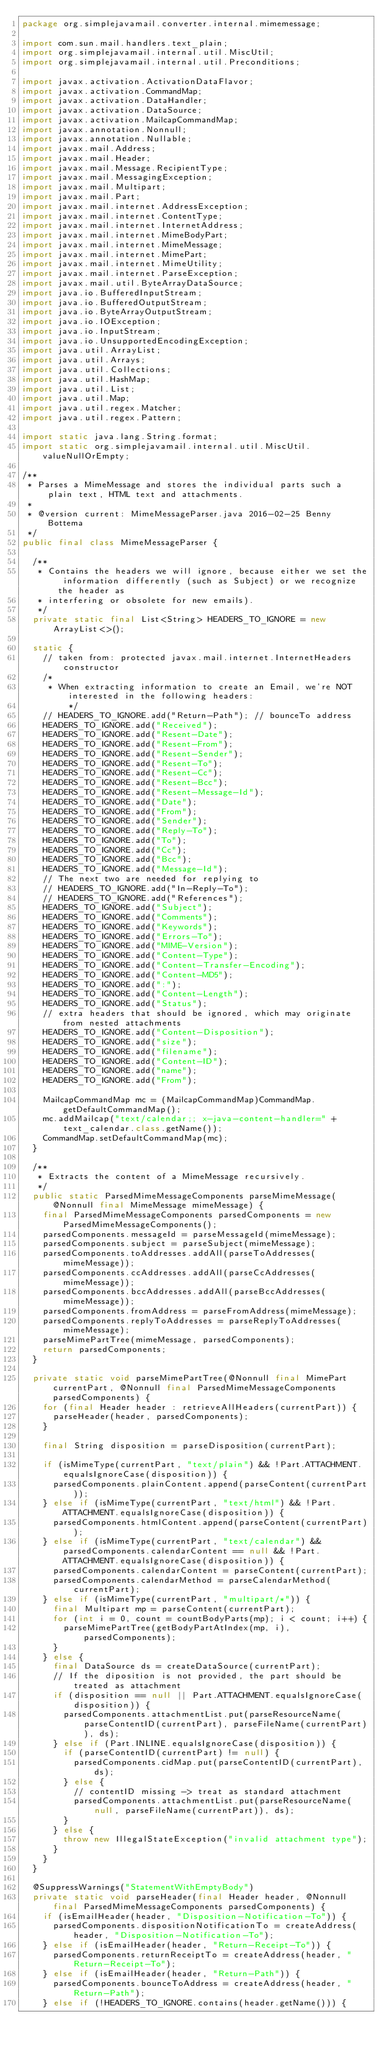<code> <loc_0><loc_0><loc_500><loc_500><_Java_>package org.simplejavamail.converter.internal.mimemessage;

import com.sun.mail.handlers.text_plain;
import org.simplejavamail.internal.util.MiscUtil;
import org.simplejavamail.internal.util.Preconditions;

import javax.activation.ActivationDataFlavor;
import javax.activation.CommandMap;
import javax.activation.DataHandler;
import javax.activation.DataSource;
import javax.activation.MailcapCommandMap;
import javax.annotation.Nonnull;
import javax.annotation.Nullable;
import javax.mail.Address;
import javax.mail.Header;
import javax.mail.Message.RecipientType;
import javax.mail.MessagingException;
import javax.mail.Multipart;
import javax.mail.Part;
import javax.mail.internet.AddressException;
import javax.mail.internet.ContentType;
import javax.mail.internet.InternetAddress;
import javax.mail.internet.MimeBodyPart;
import javax.mail.internet.MimeMessage;
import javax.mail.internet.MimePart;
import javax.mail.internet.MimeUtility;
import javax.mail.internet.ParseException;
import javax.mail.util.ByteArrayDataSource;
import java.io.BufferedInputStream;
import java.io.BufferedOutputStream;
import java.io.ByteArrayOutputStream;
import java.io.IOException;
import java.io.InputStream;
import java.io.UnsupportedEncodingException;
import java.util.ArrayList;
import java.util.Arrays;
import java.util.Collections;
import java.util.HashMap;
import java.util.List;
import java.util.Map;
import java.util.regex.Matcher;
import java.util.regex.Pattern;

import static java.lang.String.format;
import static org.simplejavamail.internal.util.MiscUtil.valueNullOrEmpty;

/**
 * Parses a MimeMessage and stores the individual parts such a plain text, HTML text and attachments.
 *
 * @version current: MimeMessageParser.java 2016-02-25 Benny Bottema
 */
public final class MimeMessageParser {
	
	/**
	 * Contains the headers we will ignore, because either we set the information differently (such as Subject) or we recognize the header as
	 * interfering or obsolete for new emails).
	 */
	private static final List<String> HEADERS_TO_IGNORE = new ArrayList<>();

	static {
		// taken from: protected javax.mail.internet.InternetHeaders constructor
		/*
		 * When extracting information to create an Email, we're NOT interested in the following headers:
         */
		// HEADERS_TO_IGNORE.add("Return-Path"); // bounceTo address
		HEADERS_TO_IGNORE.add("Received");
		HEADERS_TO_IGNORE.add("Resent-Date");
		HEADERS_TO_IGNORE.add("Resent-From");
		HEADERS_TO_IGNORE.add("Resent-Sender");
		HEADERS_TO_IGNORE.add("Resent-To");
		HEADERS_TO_IGNORE.add("Resent-Cc");
		HEADERS_TO_IGNORE.add("Resent-Bcc");
		HEADERS_TO_IGNORE.add("Resent-Message-Id");
		HEADERS_TO_IGNORE.add("Date");
		HEADERS_TO_IGNORE.add("From");
		HEADERS_TO_IGNORE.add("Sender");
		HEADERS_TO_IGNORE.add("Reply-To");
		HEADERS_TO_IGNORE.add("To");
		HEADERS_TO_IGNORE.add("Cc");
		HEADERS_TO_IGNORE.add("Bcc");
		HEADERS_TO_IGNORE.add("Message-Id");
		// The next two are needed for replying to
		// HEADERS_TO_IGNORE.add("In-Reply-To");
		// HEADERS_TO_IGNORE.add("References");
		HEADERS_TO_IGNORE.add("Subject");
		HEADERS_TO_IGNORE.add("Comments");
		HEADERS_TO_IGNORE.add("Keywords");
		HEADERS_TO_IGNORE.add("Errors-To");
		HEADERS_TO_IGNORE.add("MIME-Version");
		HEADERS_TO_IGNORE.add("Content-Type");
		HEADERS_TO_IGNORE.add("Content-Transfer-Encoding");
		HEADERS_TO_IGNORE.add("Content-MD5");
		HEADERS_TO_IGNORE.add(":");
		HEADERS_TO_IGNORE.add("Content-Length");
		HEADERS_TO_IGNORE.add("Status");
		// extra headers that should be ignored, which may originate from nested attachments
		HEADERS_TO_IGNORE.add("Content-Disposition");
		HEADERS_TO_IGNORE.add("size");
		HEADERS_TO_IGNORE.add("filename");
		HEADERS_TO_IGNORE.add("Content-ID");
		HEADERS_TO_IGNORE.add("name");
		HEADERS_TO_IGNORE.add("From");
		
		MailcapCommandMap mc = (MailcapCommandMap)CommandMap.getDefaultCommandMap();
		mc.addMailcap("text/calendar;; x-java-content-handler=" + text_calendar.class.getName());
		CommandMap.setDefaultCommandMap(mc);
	}

	/**
	 * Extracts the content of a MimeMessage recursively.
	 */
	public static ParsedMimeMessageComponents parseMimeMessage(@Nonnull final MimeMessage mimeMessage) {
		final ParsedMimeMessageComponents parsedComponents = new ParsedMimeMessageComponents();
		parsedComponents.messageId = parseMessageId(mimeMessage);
		parsedComponents.subject = parseSubject(mimeMessage);
		parsedComponents.toAddresses.addAll(parseToAddresses(mimeMessage));
		parsedComponents.ccAddresses.addAll(parseCcAddresses(mimeMessage));
		parsedComponents.bccAddresses.addAll(parseBccAddresses(mimeMessage));
		parsedComponents.fromAddress = parseFromAddress(mimeMessage);
		parsedComponents.replyToAddresses = parseReplyToAddresses(mimeMessage);
		parseMimePartTree(mimeMessage, parsedComponents);
		return parsedComponents;
	}
	
	private static void parseMimePartTree(@Nonnull final MimePart currentPart, @Nonnull final ParsedMimeMessageComponents parsedComponents) {
		for (final Header header : retrieveAllHeaders(currentPart)) {
			parseHeader(header, parsedComponents);
		}
		
		final String disposition = parseDisposition(currentPart);
		
		if (isMimeType(currentPart, "text/plain") && !Part.ATTACHMENT.equalsIgnoreCase(disposition)) {
			parsedComponents.plainContent.append(parseContent(currentPart));
		} else if (isMimeType(currentPart, "text/html") && !Part.ATTACHMENT.equalsIgnoreCase(disposition)) {
			parsedComponents.htmlContent.append(parseContent(currentPart));
		} else if (isMimeType(currentPart, "text/calendar") && parsedComponents.calendarContent == null && !Part.ATTACHMENT.equalsIgnoreCase(disposition)) {
			parsedComponents.calendarContent = parseContent(currentPart);
			parsedComponents.calendarMethod = parseCalendarMethod(currentPart);
		} else if (isMimeType(currentPart, "multipart/*")) {
			final Multipart mp = parseContent(currentPart);
			for (int i = 0, count = countBodyParts(mp); i < count; i++) {
				parseMimePartTree(getBodyPartAtIndex(mp, i), parsedComponents);
			}
		} else {
			final DataSource ds = createDataSource(currentPart);
			// If the diposition is not provided, the part should be treated as attachment
			if (disposition == null || Part.ATTACHMENT.equalsIgnoreCase(disposition)) {
				parsedComponents.attachmentList.put(parseResourceName(parseContentID(currentPart), parseFileName(currentPart)), ds);
			} else if (Part.INLINE.equalsIgnoreCase(disposition)) {
				if (parseContentID(currentPart) != null) {
					parsedComponents.cidMap.put(parseContentID(currentPart), ds);
				} else {
					// contentID missing -> treat as standard attachment
					parsedComponents.attachmentList.put(parseResourceName(null, parseFileName(currentPart)), ds);
				}
			} else {
				throw new IllegalStateException("invalid attachment type");
			}
		}
	}
	
	@SuppressWarnings("StatementWithEmptyBody")
	private static void parseHeader(final Header header, @Nonnull final ParsedMimeMessageComponents parsedComponents) {
		if (isEmailHeader(header, "Disposition-Notification-To")) {
			parsedComponents.dispositionNotificationTo = createAddress(header, "Disposition-Notification-To");
		} else if (isEmailHeader(header, "Return-Receipt-To")) {
			parsedComponents.returnReceiptTo = createAddress(header, "Return-Receipt-To");
		} else if (isEmailHeader(header, "Return-Path")) {
			parsedComponents.bounceToAddress = createAddress(header, "Return-Path");
		} else if (!HEADERS_TO_IGNORE.contains(header.getName())) {</code> 